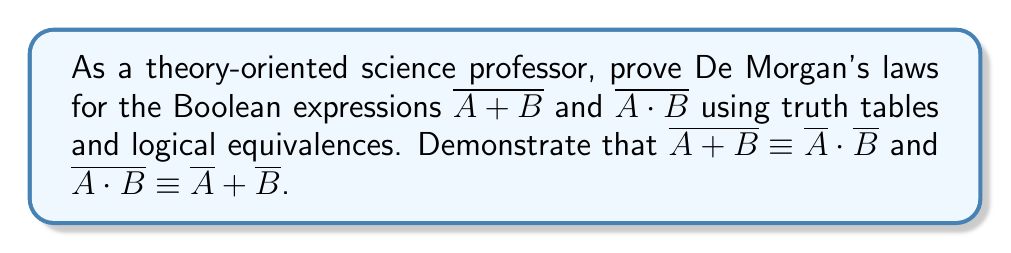Solve this math problem. Let's prove De Morgan's laws step by step using truth tables and logical equivalences:

1. First, let's create truth tables for $\overline{A + B}$ and $\overline{A} \cdot \overline{B}$:

   A | B | A + B | $\overline{A + B}$ | $\overline{A}$ | $\overline{B}$ | $\overline{A} \cdot \overline{B}$
   0 | 0 |   0   |        1          |      1        |      1        |          1
   0 | 1 |   1   |        0          |      1        |      0        |          0
   1 | 0 |   1   |        0          |      0        |      1        |          0
   1 | 1 |   1   |        0          |      0        |      0        |          0

2. Observe that the columns for $\overline{A + B}$ and $\overline{A} \cdot \overline{B}$ are identical, proving that $\overline{A + B} \equiv \overline{A} \cdot \overline{B}$.

3. Now, let's create truth tables for $\overline{A \cdot B}$ and $\overline{A} + \overline{B}$:

   A | B | A · B | $\overline{A \cdot B}$ | $\overline{A}$ | $\overline{B}$ | $\overline{A} + \overline{B}$
   0 | 0 |   0   |        1          |      1        |      1        |          1
   0 | 1 |   0   |        1          |      1        |      0        |          1
   1 | 0 |   0   |        1          |      0        |      1        |          1
   1 | 1 |   1   |        0          |      0        |      0        |          0

4. Observe that the columns for $\overline{A \cdot B}$ and $\overline{A} + \overline{B}$ are identical, proving that $\overline{A \cdot B} \equiv \overline{A} + \overline{B}$.

5. To further demonstrate the logical equivalences, we can use the following steps:

   For $\overline{A + B} \equiv \overline{A} \cdot \overline{B}$:
   $$\overline{A + B} \equiv \overline{A} \cdot \overline{B}$$
   $$\equiv \lnot(A \lor B) \equiv \lnot A \land \lnot B$$

   For $\overline{A \cdot B} \equiv \overline{A} + \overline{B}$:
   $$\overline{A \cdot B} \equiv \overline{A} + \overline{B}$$
   $$\equiv \lnot(A \land B) \equiv \lnot A \lor \lnot B$$

6. These logical equivalences can be derived using the following properties:
   - Double negation: $\lnot(\lnot A) \equiv A$
   - Commutative laws: $A \lor B \equiv B \lor A$ and $A \land B \equiv B \land A$
   - Distributive laws: $A \lor (B \land C) \equiv (A \lor B) \land (A \lor C)$ and $A \land (B \lor C) \equiv (A \land B) \lor (A \land C)$

By using both truth tables and logical equivalences, we have proven De Morgan's laws for the given Boolean expressions.
Answer: De Morgan's laws are proven: $\overline{A + B} \equiv \overline{A} \cdot \overline{B}$ and $\overline{A \cdot B} \equiv \overline{A} + \overline{B}$. 